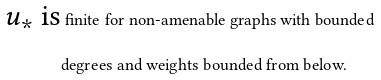Convert formula to latex. <formula><loc_0><loc_0><loc_500><loc_500>\text {$u_{*}$ is} & \text { finite for non-amenable graphs with bounded} \\ & \text {degrees and weights bounded from below.}</formula> 